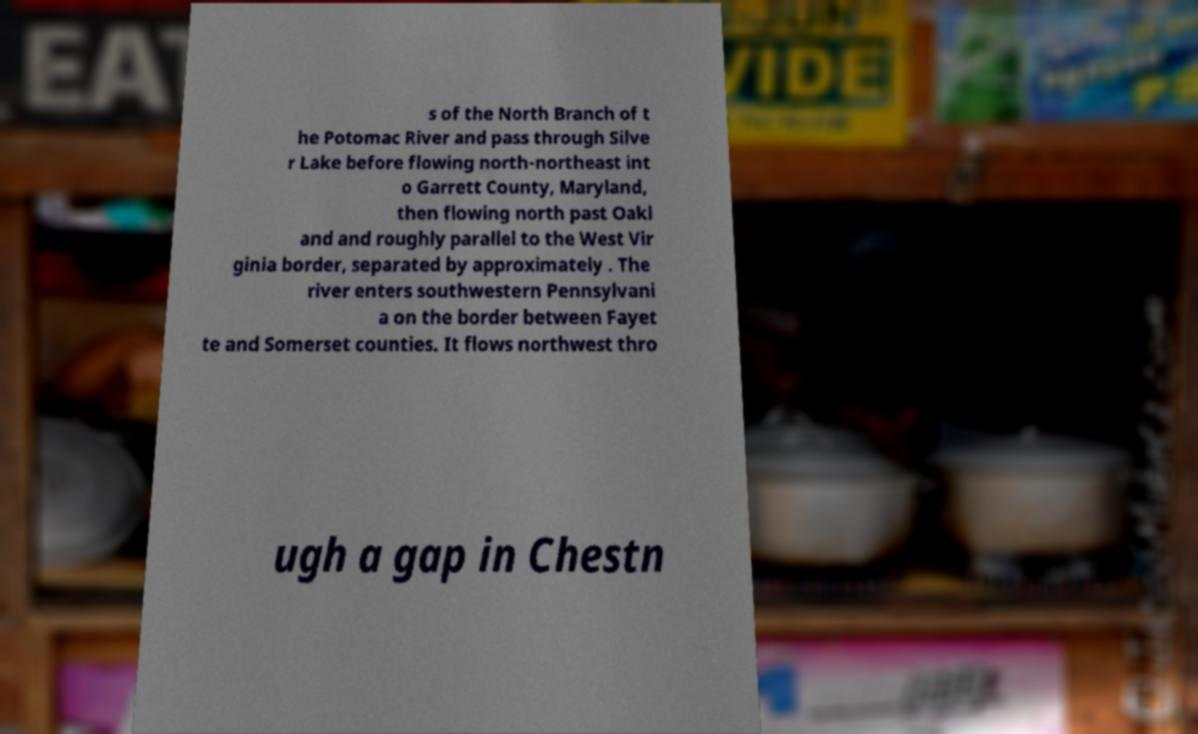What messages or text are displayed in this image? I need them in a readable, typed format. s of the North Branch of t he Potomac River and pass through Silve r Lake before flowing north-northeast int o Garrett County, Maryland, then flowing north past Oakl and and roughly parallel to the West Vir ginia border, separated by approximately . The river enters southwestern Pennsylvani a on the border between Fayet te and Somerset counties. It flows northwest thro ugh a gap in Chestn 